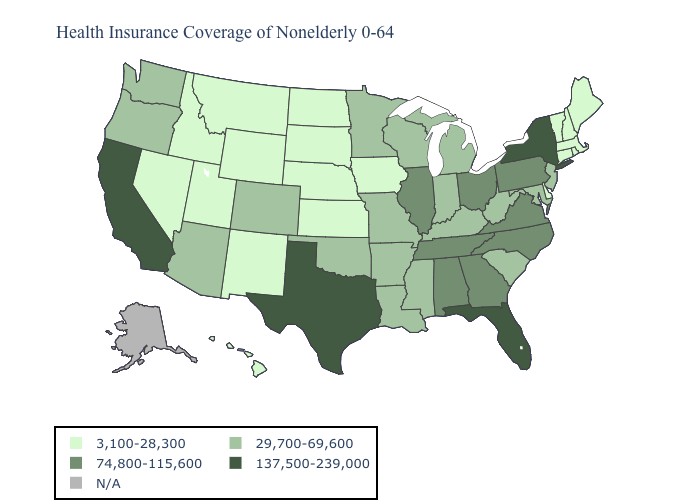What is the value of Georgia?
Give a very brief answer. 74,800-115,600. What is the value of Arizona?
Write a very short answer. 29,700-69,600. What is the lowest value in the USA?
Give a very brief answer. 3,100-28,300. Among the states that border Nebraska , does Iowa have the highest value?
Answer briefly. No. Which states hav the highest value in the MidWest?
Concise answer only. Illinois, Ohio. Does Georgia have the highest value in the USA?
Concise answer only. No. What is the value of Pennsylvania?
Concise answer only. 74,800-115,600. Name the states that have a value in the range 74,800-115,600?
Keep it brief. Alabama, Georgia, Illinois, North Carolina, Ohio, Pennsylvania, Tennessee, Virginia. Name the states that have a value in the range N/A?
Quick response, please. Alaska. What is the lowest value in the MidWest?
Concise answer only. 3,100-28,300. Name the states that have a value in the range 3,100-28,300?
Answer briefly. Connecticut, Delaware, Hawaii, Idaho, Iowa, Kansas, Maine, Massachusetts, Montana, Nebraska, Nevada, New Hampshire, New Mexico, North Dakota, Rhode Island, South Dakota, Utah, Vermont, Wyoming. Does Florida have the highest value in the USA?
Write a very short answer. Yes. Does Colorado have the highest value in the West?
Short answer required. No. Does the first symbol in the legend represent the smallest category?
Concise answer only. Yes. Does Montana have the lowest value in the USA?
Write a very short answer. Yes. 